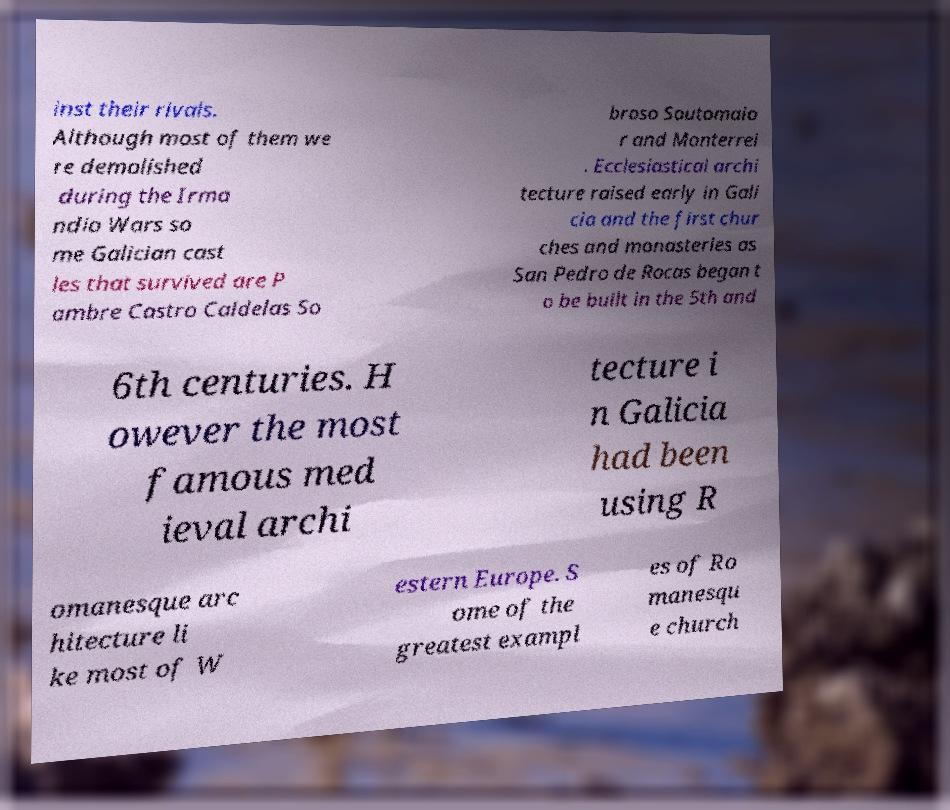Please read and relay the text visible in this image. What does it say? inst their rivals. Although most of them we re demolished during the Irma ndio Wars so me Galician cast les that survived are P ambre Castro Caldelas So broso Soutomaio r and Monterrei . Ecclesiastical archi tecture raised early in Gali cia and the first chur ches and monasteries as San Pedro de Rocas began t o be built in the 5th and 6th centuries. H owever the most famous med ieval archi tecture i n Galicia had been using R omanesque arc hitecture li ke most of W estern Europe. S ome of the greatest exampl es of Ro manesqu e church 